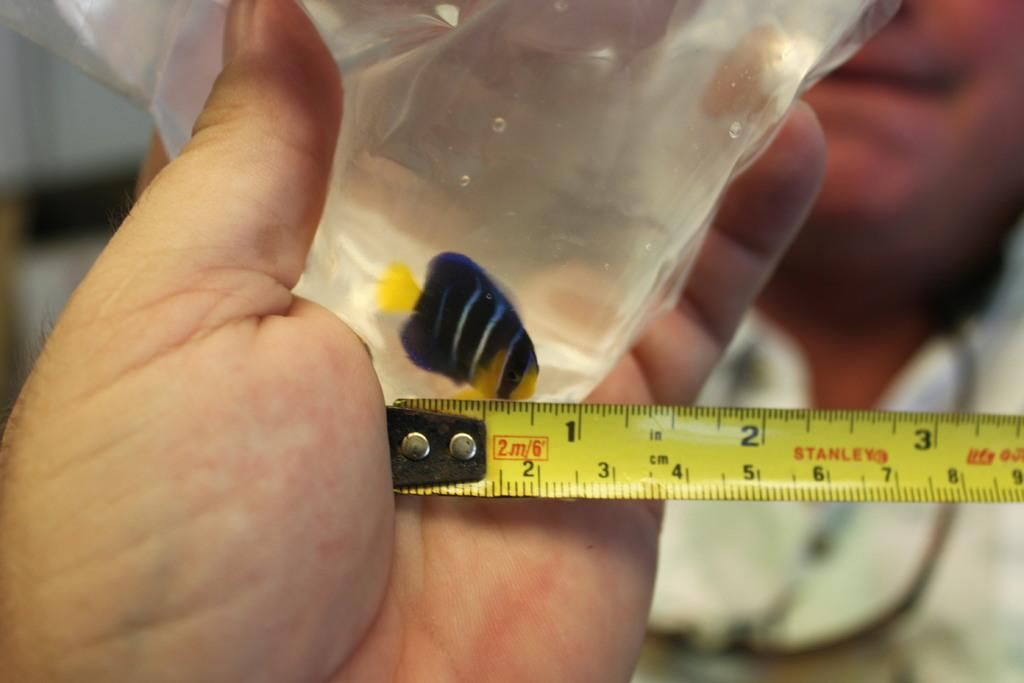<image>
Relay a brief, clear account of the picture shown. A partially extended yellow measuring tape has the name Stanley on it. 